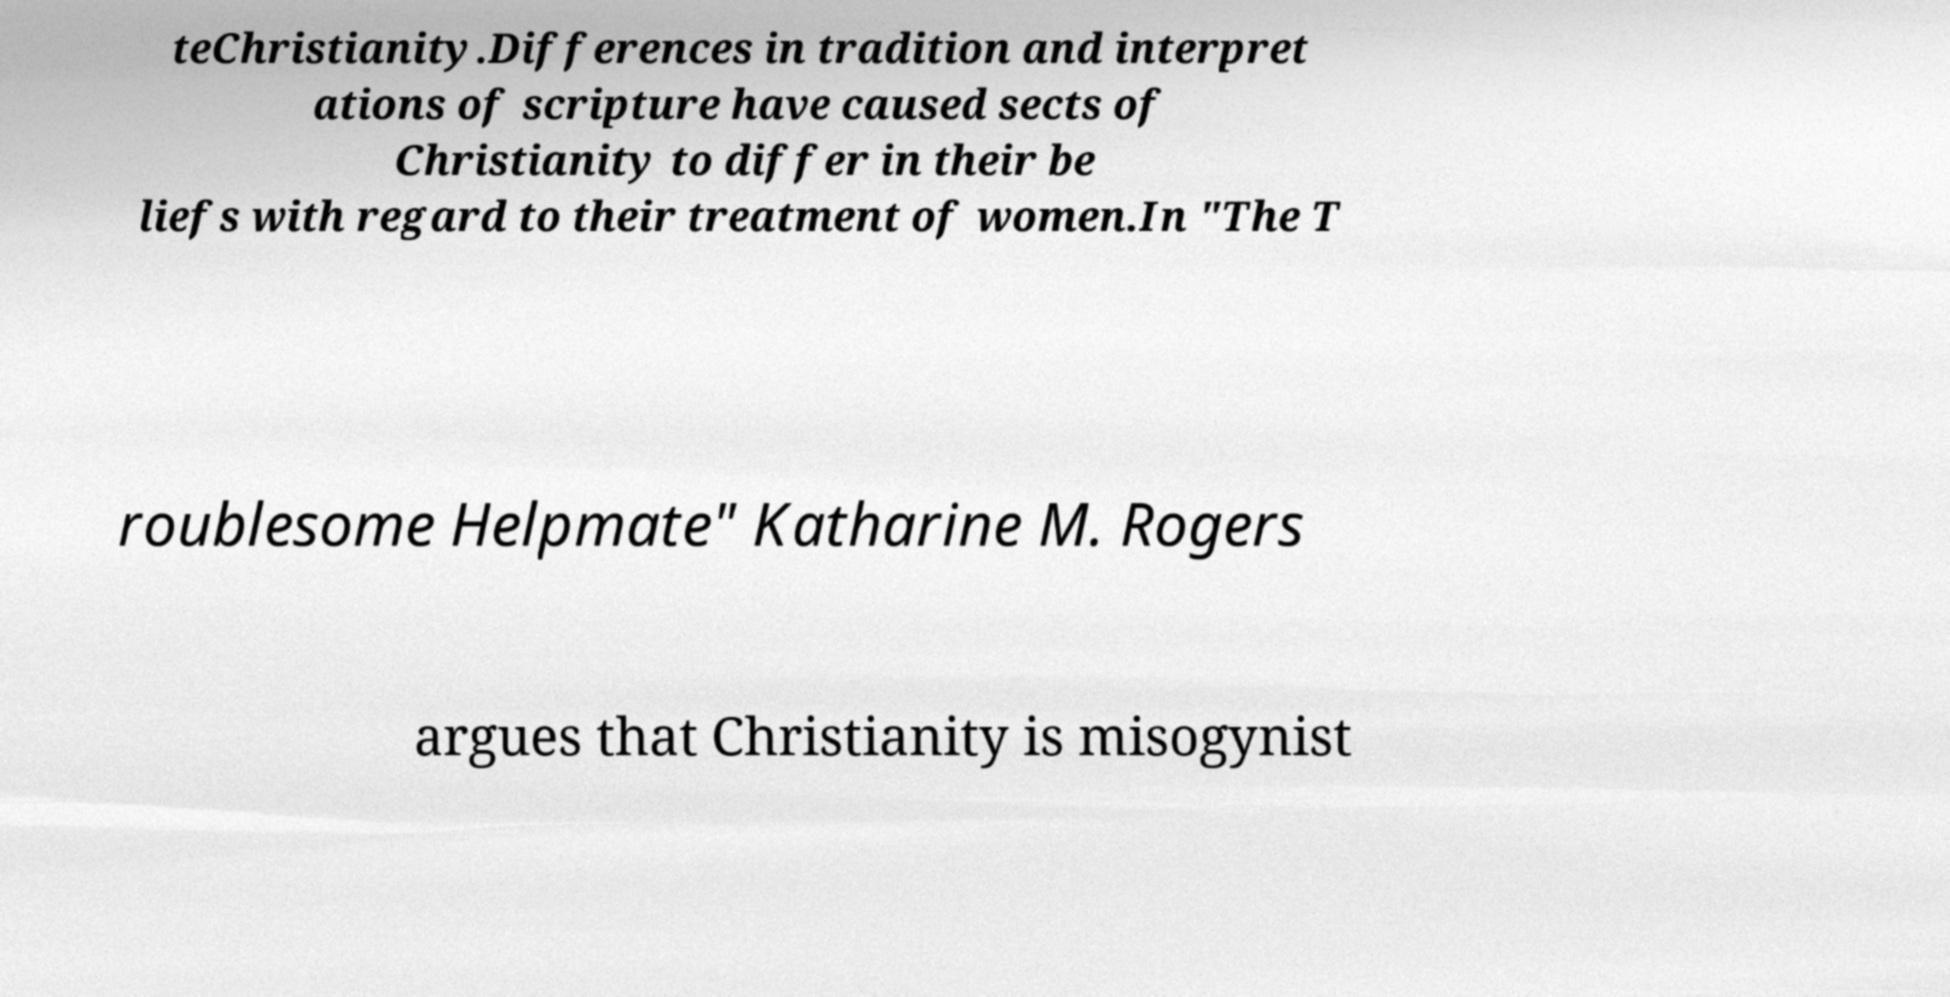Please identify and transcribe the text found in this image. teChristianity.Differences in tradition and interpret ations of scripture have caused sects of Christianity to differ in their be liefs with regard to their treatment of women.In "The T roublesome Helpmate" Katharine M. Rogers argues that Christianity is misogynist 